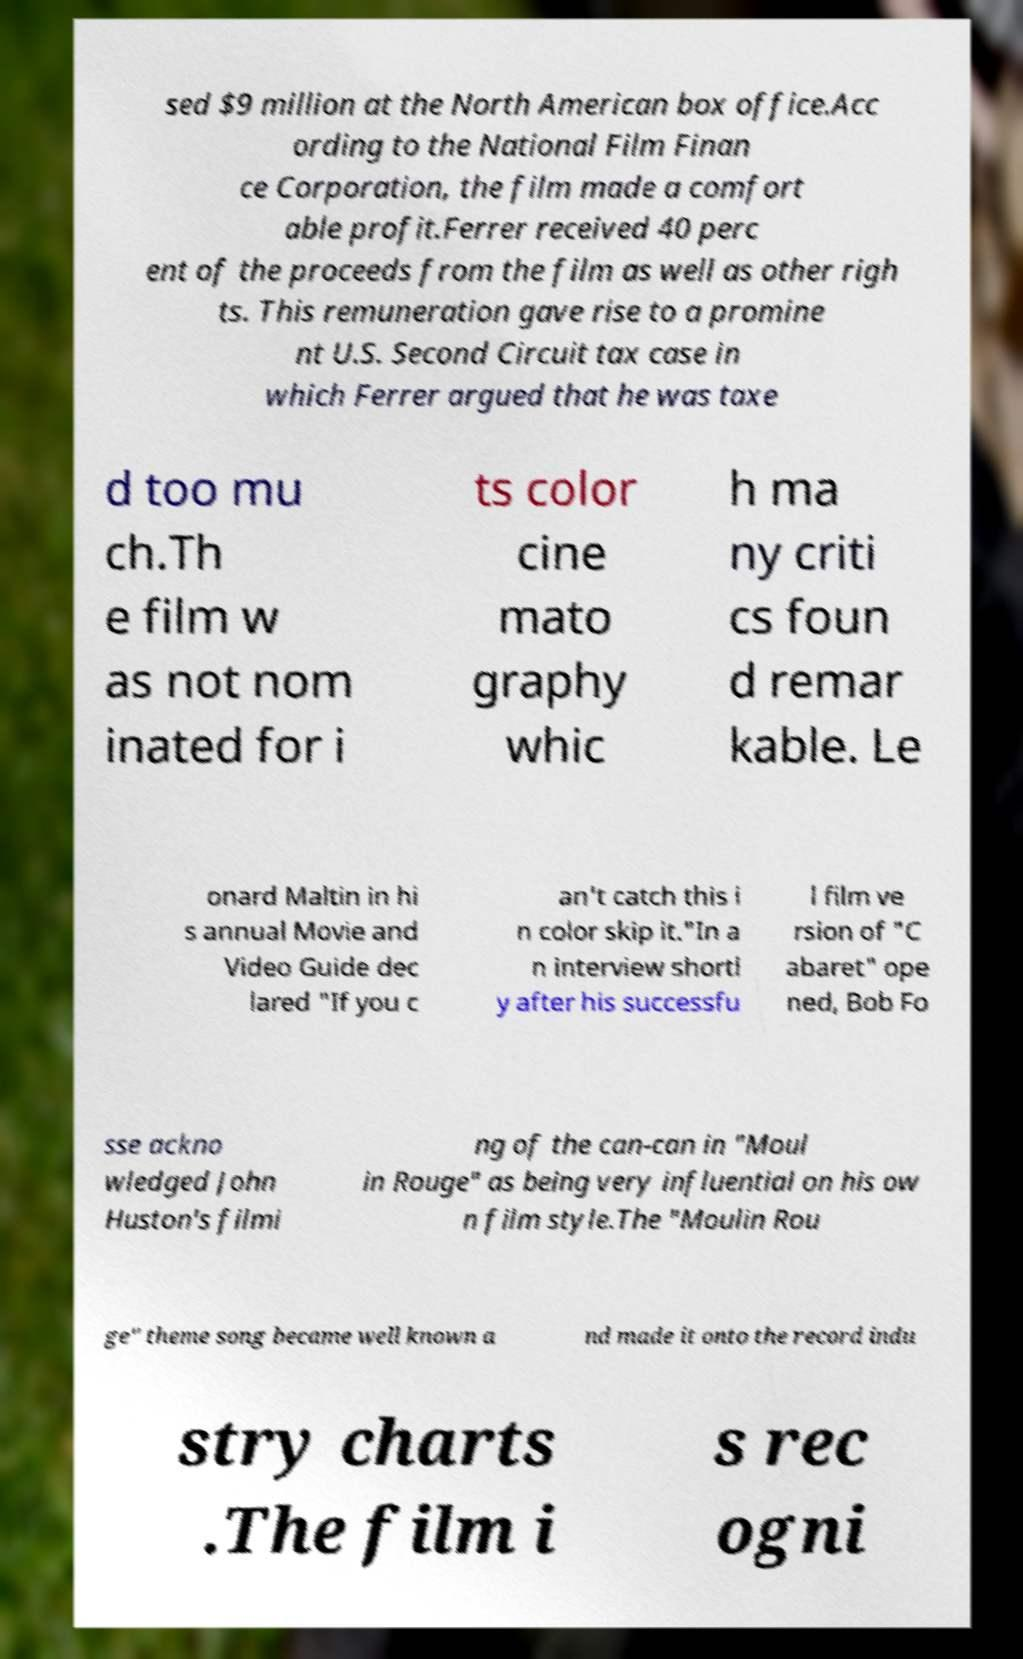I need the written content from this picture converted into text. Can you do that? sed $9 million at the North American box office.Acc ording to the National Film Finan ce Corporation, the film made a comfort able profit.Ferrer received 40 perc ent of the proceeds from the film as well as other righ ts. This remuneration gave rise to a promine nt U.S. Second Circuit tax case in which Ferrer argued that he was taxe d too mu ch.Th e film w as not nom inated for i ts color cine mato graphy whic h ma ny criti cs foun d remar kable. Le onard Maltin in hi s annual Movie and Video Guide dec lared "If you c an't catch this i n color skip it."In a n interview shortl y after his successfu l film ve rsion of "C abaret" ope ned, Bob Fo sse ackno wledged John Huston's filmi ng of the can-can in "Moul in Rouge" as being very influential on his ow n film style.The "Moulin Rou ge" theme song became well known a nd made it onto the record indu stry charts .The film i s rec ogni 